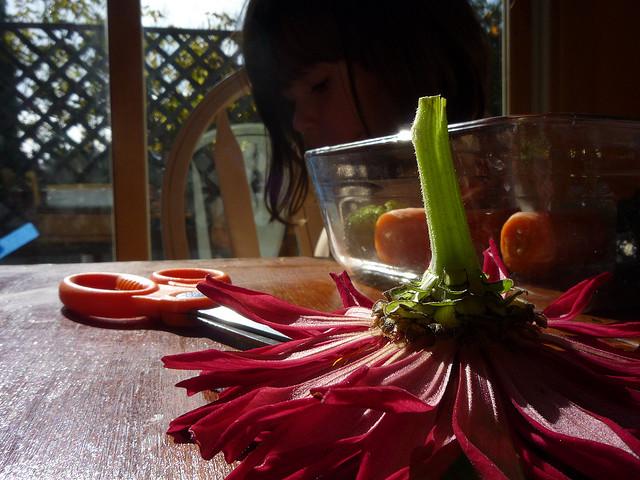What color is the flower?
Keep it brief. Red. Are the flowers in a container?
Short answer required. No. What color is the scissors handles?
Write a very short answer. Orange. Did the girl cut the flower?
Be succinct. Yes. 